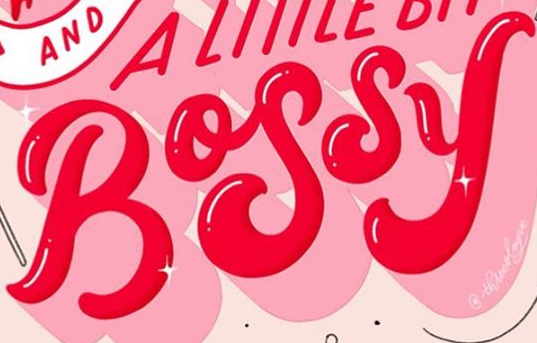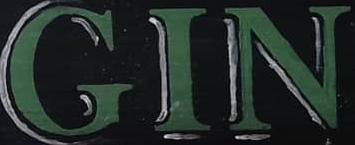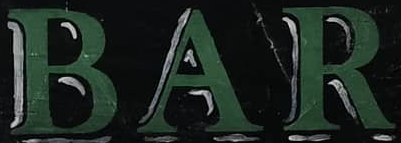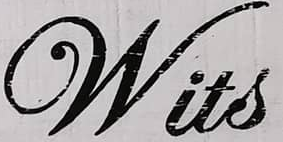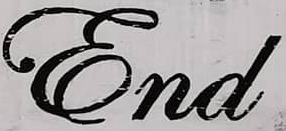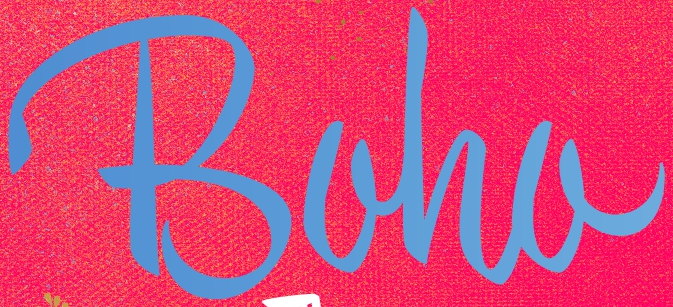What text is displayed in these images sequentially, separated by a semicolon? BOSSY; GIN; BAR; Wits; End; Boha 